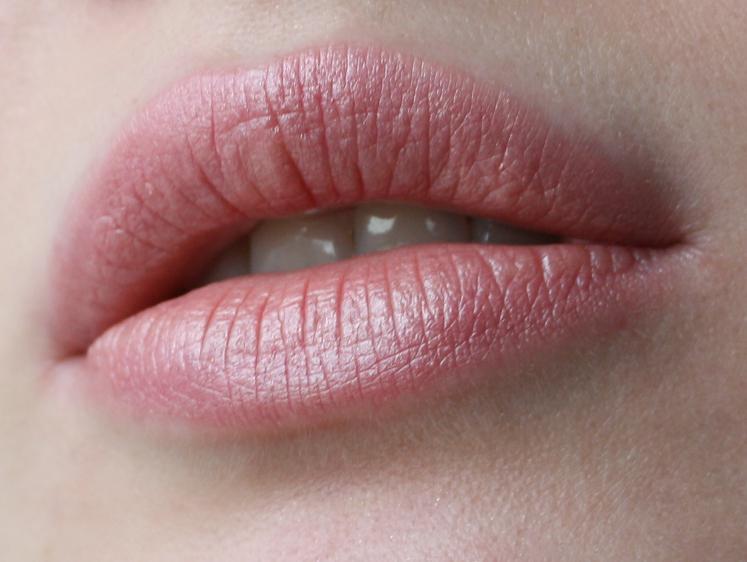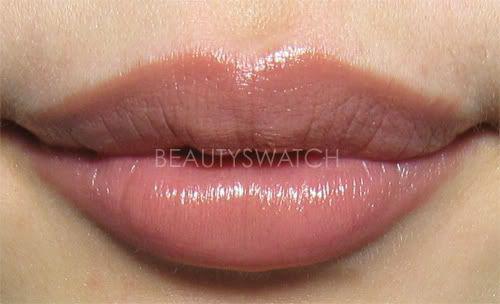The first image is the image on the left, the second image is the image on the right. Assess this claim about the two images: "One image features pink tinted lips with no teeth showing, and the other image shows multiple lipstick marks on skin.". Correct or not? Answer yes or no. No. The first image is the image on the left, the second image is the image on the right. Considering the images on both sides, is "One image shows a lipstick shade displayed on lips and the other shows a variety of shades displayed on an arm." valid? Answer yes or no. No. 